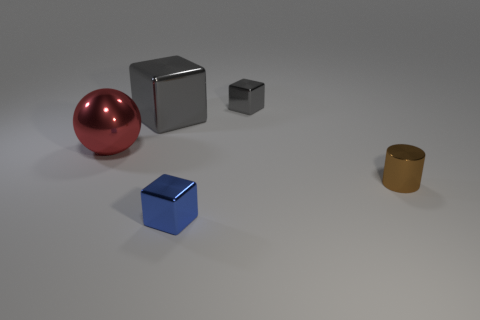Add 3 small blue objects. How many objects exist? 8 Subtract all cylinders. How many objects are left? 4 Add 4 small brown shiny cylinders. How many small brown shiny cylinders exist? 5 Subtract 0 yellow cylinders. How many objects are left? 5 Subtract all cyan cubes. Subtract all tiny metallic blocks. How many objects are left? 3 Add 5 brown cylinders. How many brown cylinders are left? 6 